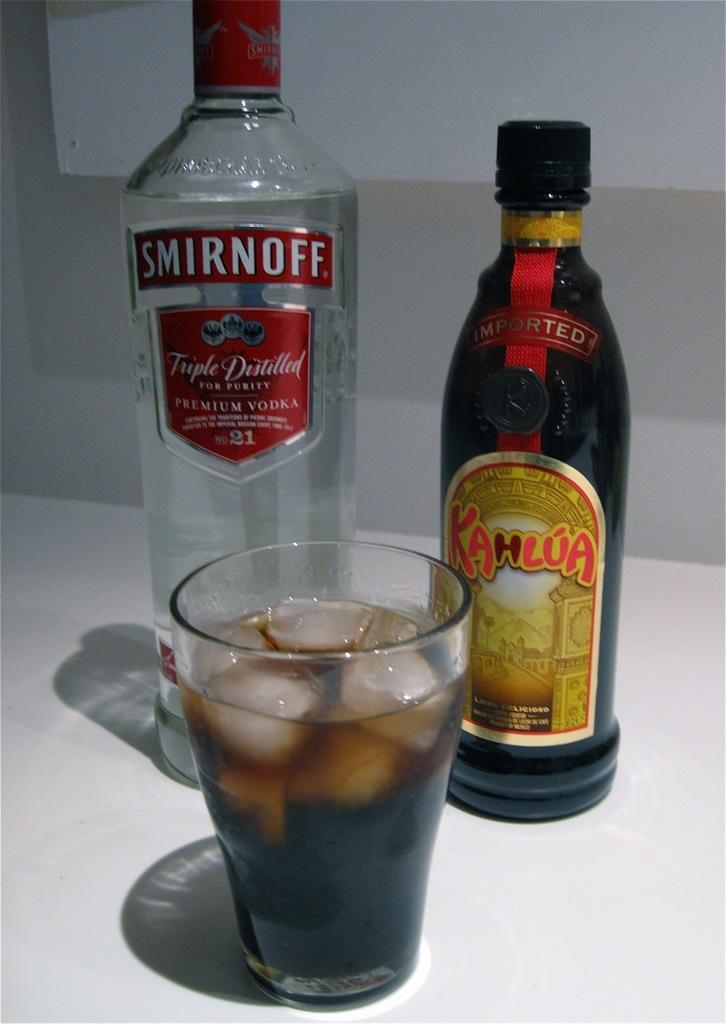<image>
Relay a brief, clear account of the picture shown. a bottle of smirnoff triple distilled for purity premium vodka in front of a glass 